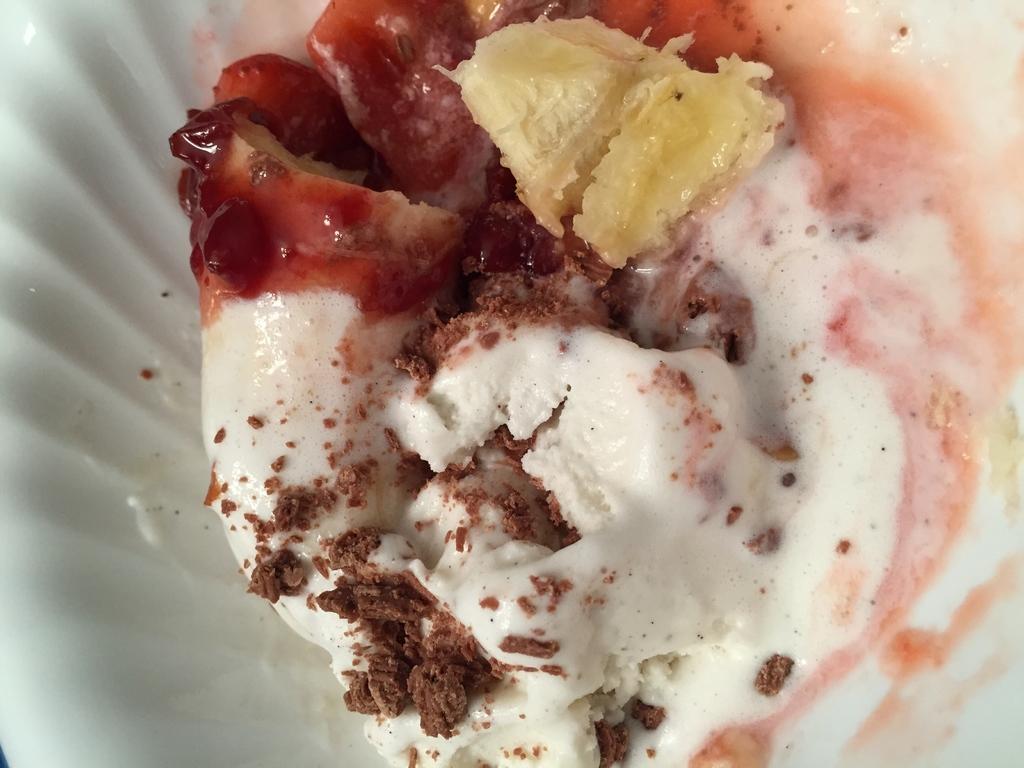Describe this image in one or two sentences. In the picture I can see food item on white color surface. 